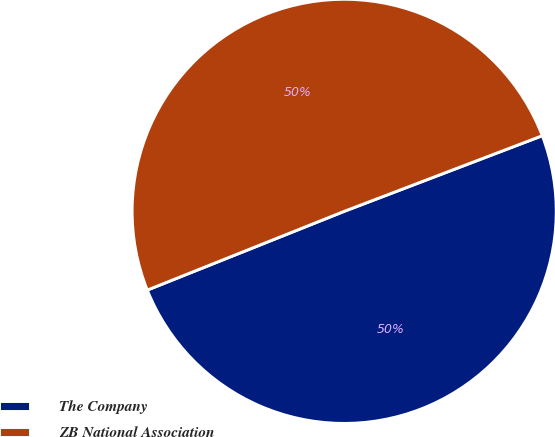<chart> <loc_0><loc_0><loc_500><loc_500><pie_chart><fcel>The Company<fcel>ZB National Association<nl><fcel>49.75%<fcel>50.25%<nl></chart> 